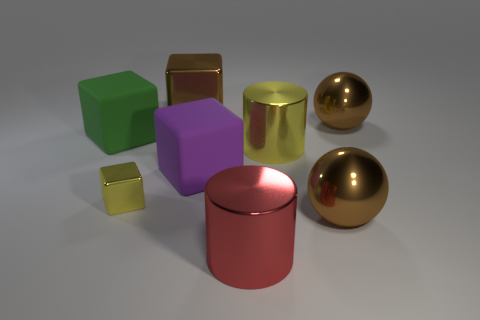There is a yellow shiny object that is in front of the yellow cylinder; is there a large metal cylinder that is on the right side of it?
Your answer should be compact. Yes. How many other things are the same shape as the purple matte thing?
Give a very brief answer. 3. Does the red metal object have the same shape as the green object?
Offer a terse response. No. There is a cube that is left of the brown cube and behind the tiny yellow object; what color is it?
Ensure brevity in your answer.  Green. The metal cylinder that is the same color as the tiny shiny cube is what size?
Give a very brief answer. Large. How many small things are green matte spheres or cubes?
Offer a terse response. 1. Is there any other thing of the same color as the tiny shiny thing?
Offer a very short reply. Yes. What material is the thing that is left of the cube in front of the matte cube that is in front of the large green rubber cube?
Your answer should be very brief. Rubber. What number of rubber objects are brown spheres or yellow cylinders?
Your response must be concise. 0. How many green things are either large matte objects or small blocks?
Provide a short and direct response. 1. 